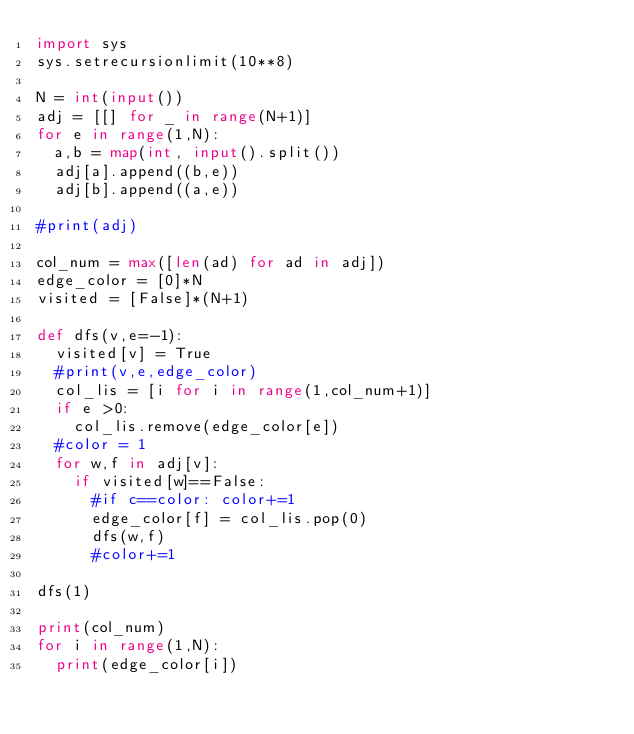<code> <loc_0><loc_0><loc_500><loc_500><_Python_>import sys
sys.setrecursionlimit(10**8)

N = int(input())
adj = [[] for _ in range(N+1)]
for e in range(1,N):
  a,b = map(int, input().split())
  adj[a].append((b,e))
  adj[b].append((a,e))

#print(adj)

col_num = max([len(ad) for ad in adj])
edge_color = [0]*N
visited = [False]*(N+1)

def dfs(v,e=-1):
  visited[v] = True
  #print(v,e,edge_color)
  col_lis = [i for i in range(1,col_num+1)]
  if e >0:
    col_lis.remove(edge_color[e])
  #color = 1
  for w,f in adj[v]:
    if visited[w]==False:
      #if c==color: color+=1
      edge_color[f] = col_lis.pop(0)
      dfs(w,f)
      #color+=1

dfs(1)

print(col_num)
for i in range(1,N):
  print(edge_color[i])</code> 